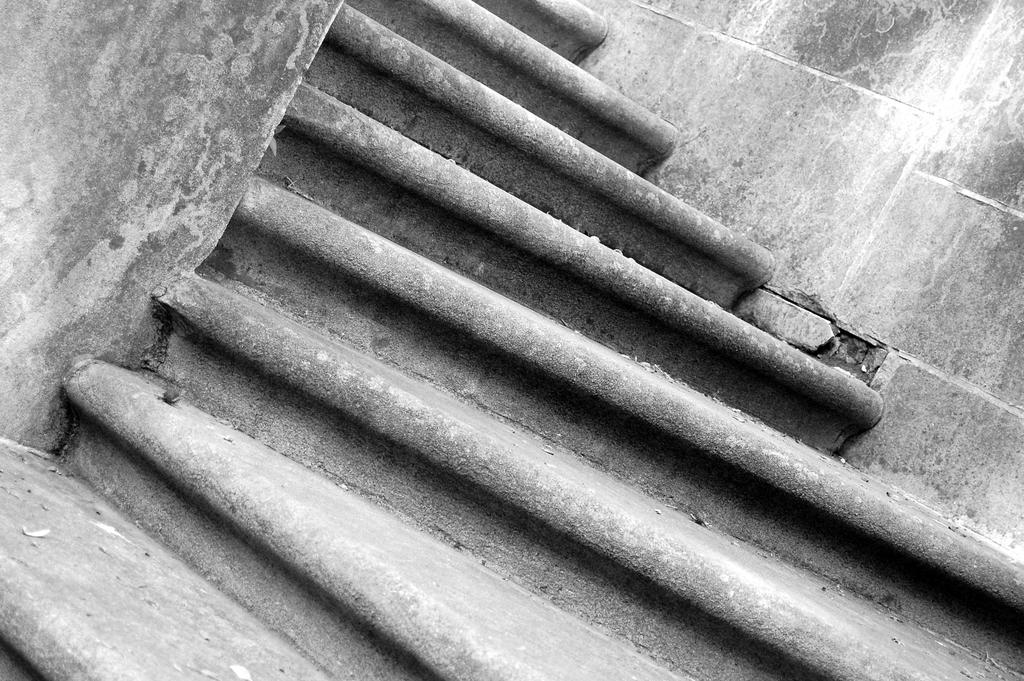What is located in the foreground area of the image? There are stairs in the foreground area of the image. What type of pie is being baked in the oven in the image? There is no oven or pie present in the image; it only features stairs in the foreground area. 